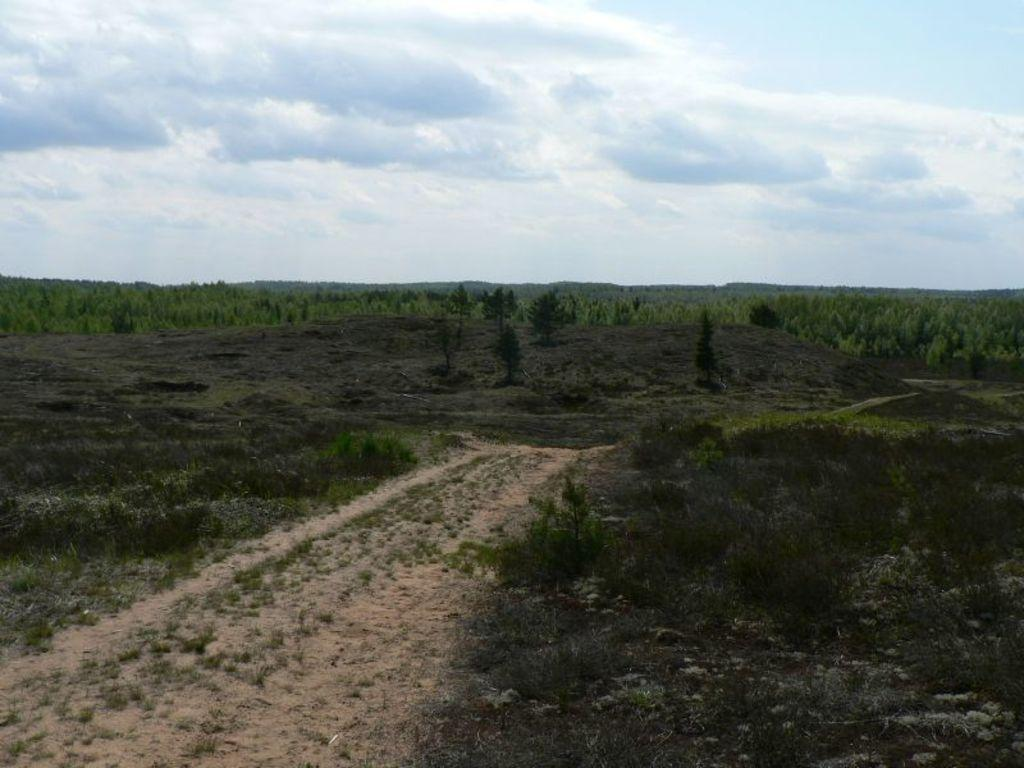What type of terrain is depicted in the image? There is land in the image, with many trees on it. What can be found at the bottom of the image? There is sand at the bottom of the image. What type of vegetation is present on the sand? There is grass on the sand. What is visible at the top of the image? The sky is visible at the top of the image. Can you see an owl perched on one of the trees in the image? There is no owl present in the image; only trees, sand, grass, and sky are visible. What type of tool is being used to dig in the sand in the image? There is no tool or digging activity depicted in the image; it only shows trees, sand, grass, and sky. 